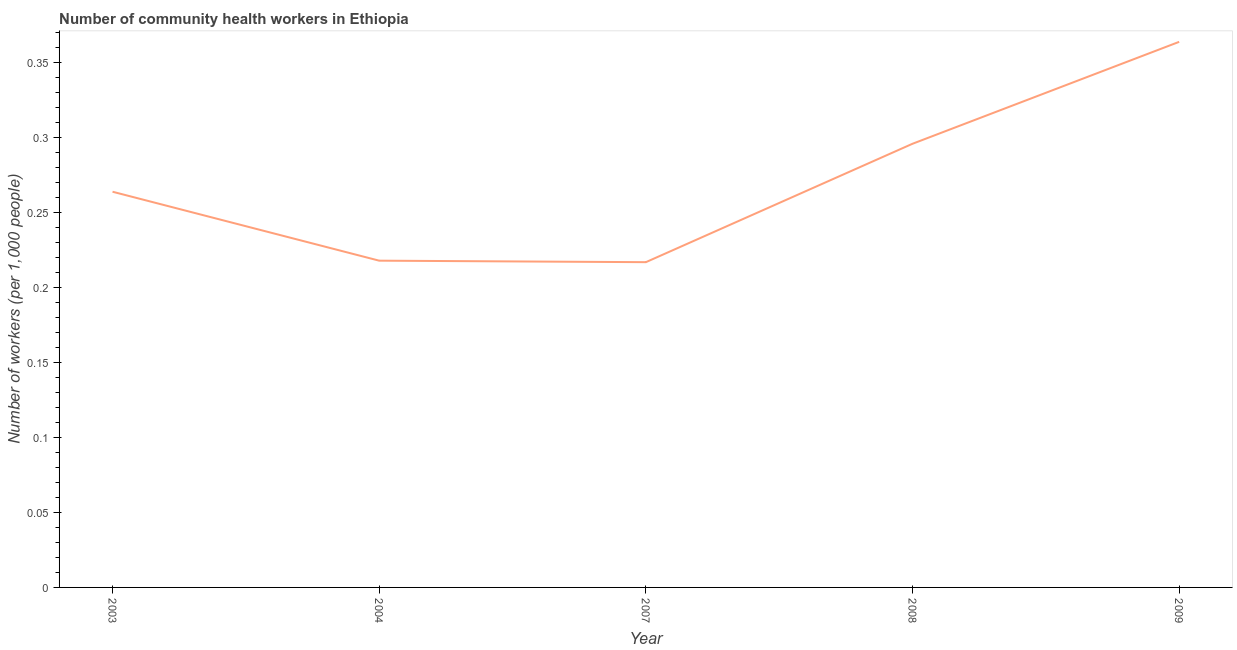What is the number of community health workers in 2009?
Provide a short and direct response. 0.36. Across all years, what is the maximum number of community health workers?
Your response must be concise. 0.36. Across all years, what is the minimum number of community health workers?
Make the answer very short. 0.22. In which year was the number of community health workers maximum?
Give a very brief answer. 2009. In which year was the number of community health workers minimum?
Your response must be concise. 2007. What is the sum of the number of community health workers?
Ensure brevity in your answer.  1.36. What is the difference between the number of community health workers in 2004 and 2009?
Your answer should be very brief. -0.15. What is the average number of community health workers per year?
Provide a short and direct response. 0.27. What is the median number of community health workers?
Provide a short and direct response. 0.26. Do a majority of the years between 2009 and 2007 (inclusive) have number of community health workers greater than 0.07 ?
Make the answer very short. No. What is the ratio of the number of community health workers in 2004 to that in 2009?
Keep it short and to the point. 0.6. What is the difference between the highest and the second highest number of community health workers?
Keep it short and to the point. 0.07. Is the sum of the number of community health workers in 2003 and 2004 greater than the maximum number of community health workers across all years?
Your response must be concise. Yes. What is the difference between the highest and the lowest number of community health workers?
Keep it short and to the point. 0.15. Does the number of community health workers monotonically increase over the years?
Your answer should be compact. No. How many years are there in the graph?
Offer a very short reply. 5. What is the difference between two consecutive major ticks on the Y-axis?
Your answer should be very brief. 0.05. Are the values on the major ticks of Y-axis written in scientific E-notation?
Offer a very short reply. No. Does the graph contain grids?
Offer a very short reply. No. What is the title of the graph?
Keep it short and to the point. Number of community health workers in Ethiopia. What is the label or title of the X-axis?
Your response must be concise. Year. What is the label or title of the Y-axis?
Your answer should be very brief. Number of workers (per 1,0 people). What is the Number of workers (per 1,000 people) in 2003?
Your response must be concise. 0.26. What is the Number of workers (per 1,000 people) of 2004?
Offer a terse response. 0.22. What is the Number of workers (per 1,000 people) of 2007?
Your answer should be compact. 0.22. What is the Number of workers (per 1,000 people) in 2008?
Offer a very short reply. 0.3. What is the Number of workers (per 1,000 people) of 2009?
Give a very brief answer. 0.36. What is the difference between the Number of workers (per 1,000 people) in 2003 and 2004?
Offer a very short reply. 0.05. What is the difference between the Number of workers (per 1,000 people) in 2003 and 2007?
Make the answer very short. 0.05. What is the difference between the Number of workers (per 1,000 people) in 2003 and 2008?
Give a very brief answer. -0.03. What is the difference between the Number of workers (per 1,000 people) in 2003 and 2009?
Make the answer very short. -0.1. What is the difference between the Number of workers (per 1,000 people) in 2004 and 2007?
Give a very brief answer. 0. What is the difference between the Number of workers (per 1,000 people) in 2004 and 2008?
Provide a short and direct response. -0.08. What is the difference between the Number of workers (per 1,000 people) in 2004 and 2009?
Provide a short and direct response. -0.15. What is the difference between the Number of workers (per 1,000 people) in 2007 and 2008?
Your answer should be very brief. -0.08. What is the difference between the Number of workers (per 1,000 people) in 2007 and 2009?
Your answer should be compact. -0.15. What is the difference between the Number of workers (per 1,000 people) in 2008 and 2009?
Your answer should be very brief. -0.07. What is the ratio of the Number of workers (per 1,000 people) in 2003 to that in 2004?
Ensure brevity in your answer.  1.21. What is the ratio of the Number of workers (per 1,000 people) in 2003 to that in 2007?
Your answer should be very brief. 1.22. What is the ratio of the Number of workers (per 1,000 people) in 2003 to that in 2008?
Make the answer very short. 0.89. What is the ratio of the Number of workers (per 1,000 people) in 2003 to that in 2009?
Provide a succinct answer. 0.72. What is the ratio of the Number of workers (per 1,000 people) in 2004 to that in 2008?
Make the answer very short. 0.74. What is the ratio of the Number of workers (per 1,000 people) in 2004 to that in 2009?
Offer a terse response. 0.6. What is the ratio of the Number of workers (per 1,000 people) in 2007 to that in 2008?
Your answer should be very brief. 0.73. What is the ratio of the Number of workers (per 1,000 people) in 2007 to that in 2009?
Your answer should be compact. 0.6. What is the ratio of the Number of workers (per 1,000 people) in 2008 to that in 2009?
Your answer should be very brief. 0.81. 